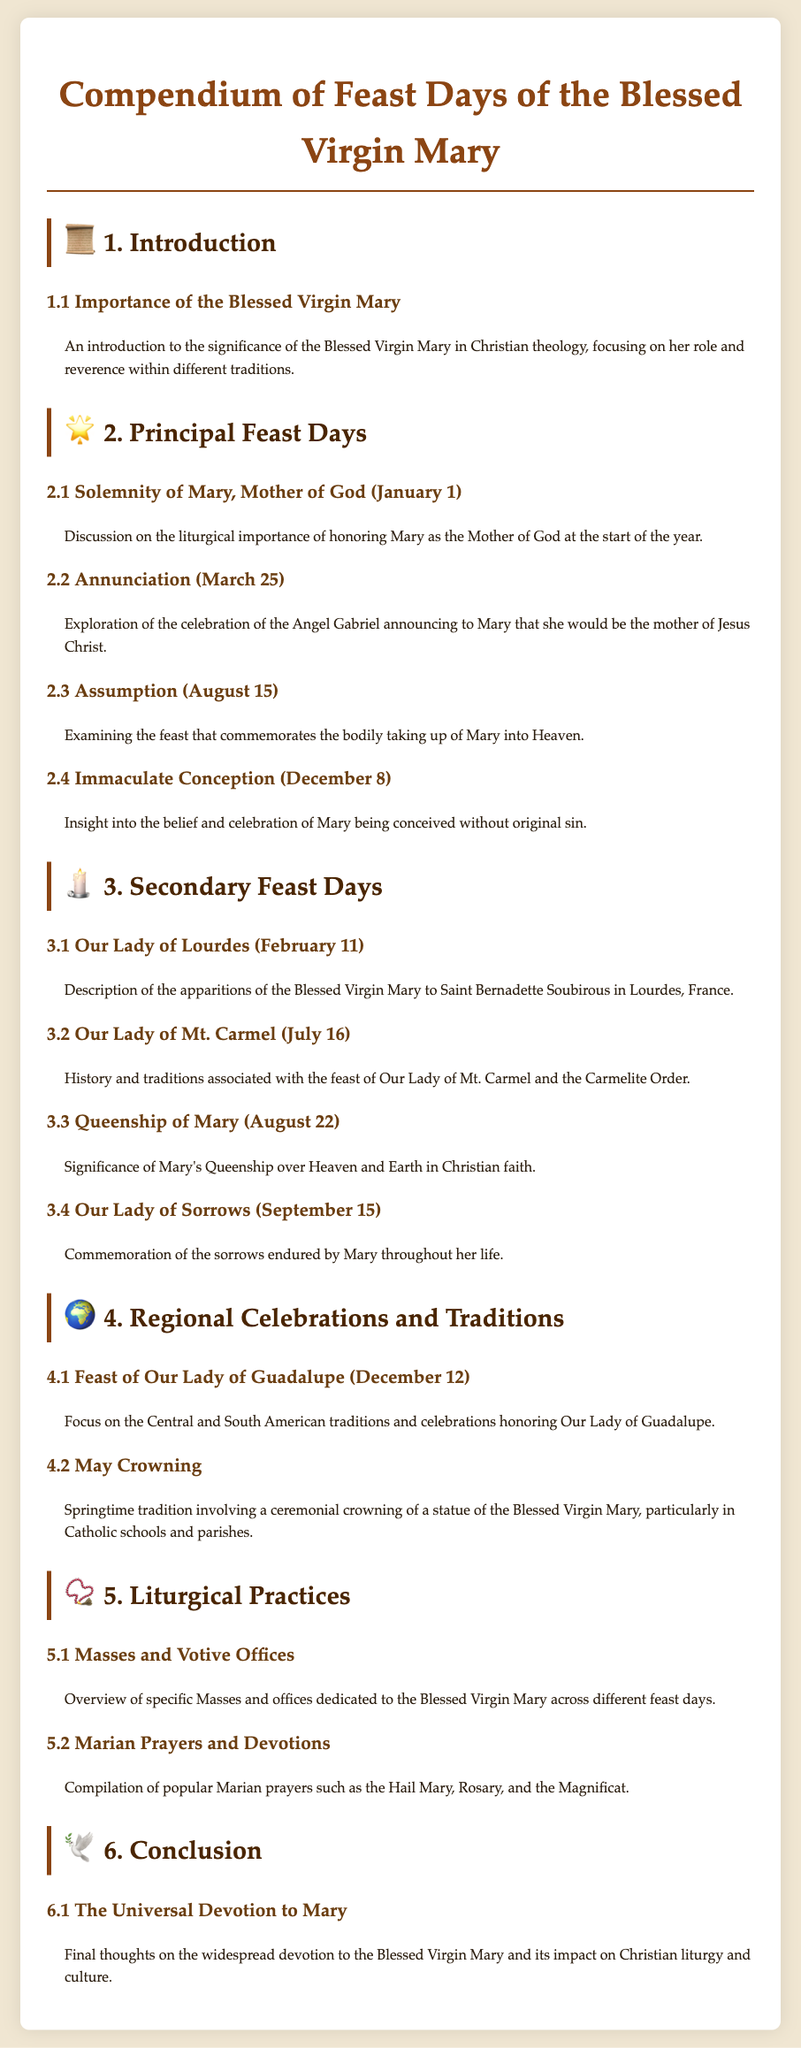What is the title of the document? The title is provided at the top of the document and indicates its primary focus on Marian feast days.
Answer: Compendium of Feast Days of the Blessed Virgin Mary What is the first principal feast day listed? The first principal feast day is mentioned under the appropriate section, representing its significance.
Answer: Solemnity of Mary, Mother of God (January 1) On which date is the Annunciation celebrated? The document specifies the date of the Annunciation celebration within the festival listing.
Answer: March 25 What does May Crowning involve? The document describes the tradition associated with May Crowning, a specific celebration related to Mary.
Answer: Ceremonial crowning of a statue of the Blessed Virgin Mary How many secondary feast days are mentioned? The document lists the secondary feast days and their respective details, which can be counted.
Answer: Four What is the significance of the Assumption? The document briefly explains the importance of the Assumption in relation to Mary.
Answer: Bodily taking up of Mary into Heaven What year does the document start with for feast days? The document starts the year with the first feast day, indicating the chronological arrangement of dates.
Answer: January 1 What is highlighted under Regional Celebrations and Traditions? The document specifies regional practices associated with Marian feast days, particularly in certain regions.
Answer: Focus on the Central and South American traditions What are Marian prayers and devotions? The document contains a section that details various typical prayers dedicated to the Blessed Virgin Mary.
Answer: Popular Marian prayers such as the Hail Mary, Rosary, and the Magnificat 